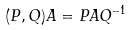Convert formula to latex. <formula><loc_0><loc_0><loc_500><loc_500>( P , Q ) A = P A Q ^ { - 1 }</formula> 